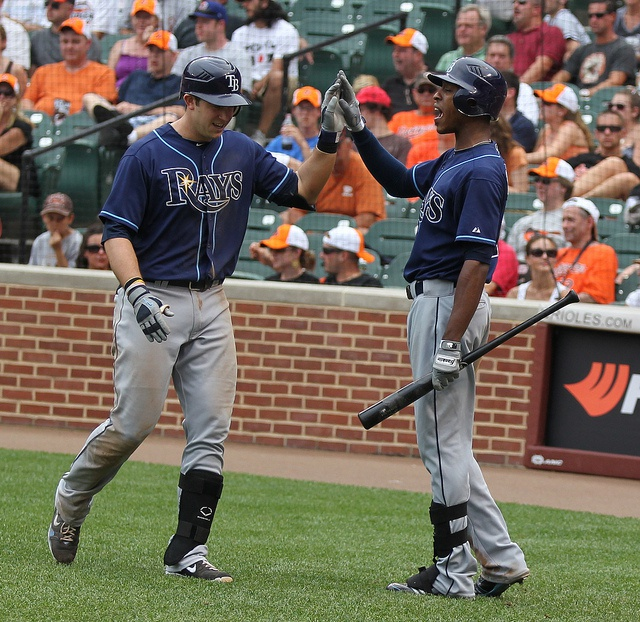Describe the objects in this image and their specific colors. I can see people in brown, black, gray, and lavender tones, people in brown, black, darkgray, gray, and navy tones, people in brown, black, darkgray, gray, and navy tones, people in brown, salmon, and red tones, and people in brown, gray, black, and darkgray tones in this image. 